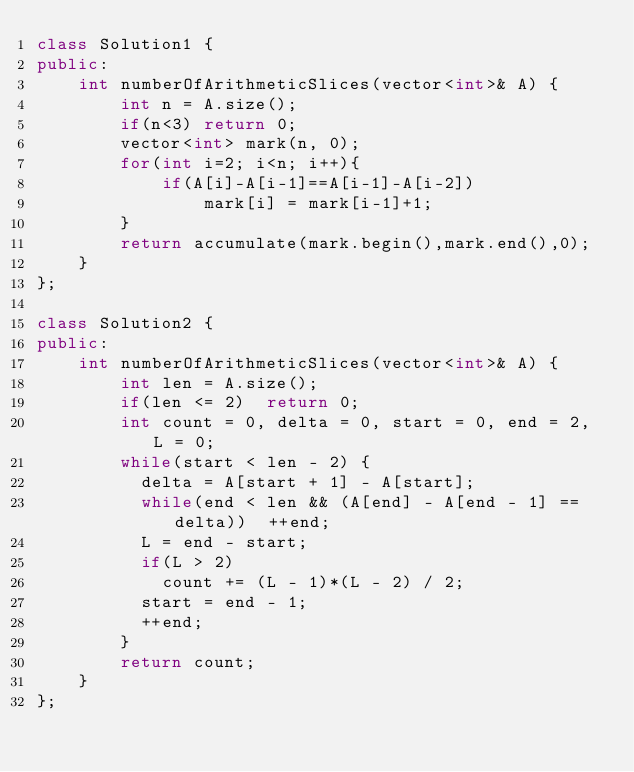Convert code to text. <code><loc_0><loc_0><loc_500><loc_500><_C++_>class Solution1 {
public:
    int numberOfArithmeticSlices(vector<int>& A) {
        int n = A.size();
        if(n<3) return 0;
        vector<int> mark(n, 0);
        for(int i=2; i<n; i++){
            if(A[i]-A[i-1]==A[i-1]-A[i-2])
                mark[i] = mark[i-1]+1;
        }
        return accumulate(mark.begin(),mark.end(),0);
    }
};

class Solution2 {
public:
    int numberOfArithmeticSlices(vector<int>& A) {
        int len = A.size();
        if(len <= 2)	return 0;
        int count = 0, delta = 0, start = 0, end = 2, L = 0;
        while(start < len - 2) {
        	delta = A[start + 1] - A[start];
        	while(end < len && (A[end] - A[end - 1] == delta))	++end;
        	L = end - start;
        	if(L > 2)
        		count += (L - 1)*(L - 2) / 2;
        	start = end - 1;
        	++end;
        }
        return count;
    }
};

</code> 